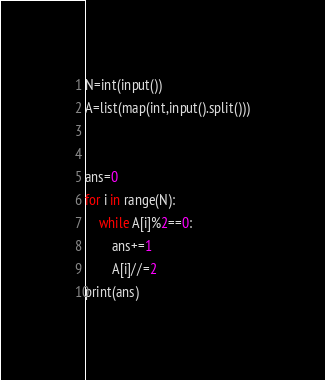<code> <loc_0><loc_0><loc_500><loc_500><_Python_>N=int(input())
A=list(map(int,input().split()))


ans=0
for i in range(N):
    while A[i]%2==0:
        ans+=1
        A[i]//=2
print(ans)</code> 